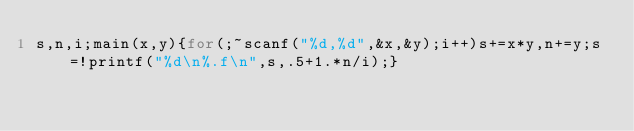<code> <loc_0><loc_0><loc_500><loc_500><_C_>s,n,i;main(x,y){for(;~scanf("%d,%d",&x,&y);i++)s+=x*y,n+=y;s=!printf("%d\n%.f\n",s,.5+1.*n/i);}</code> 